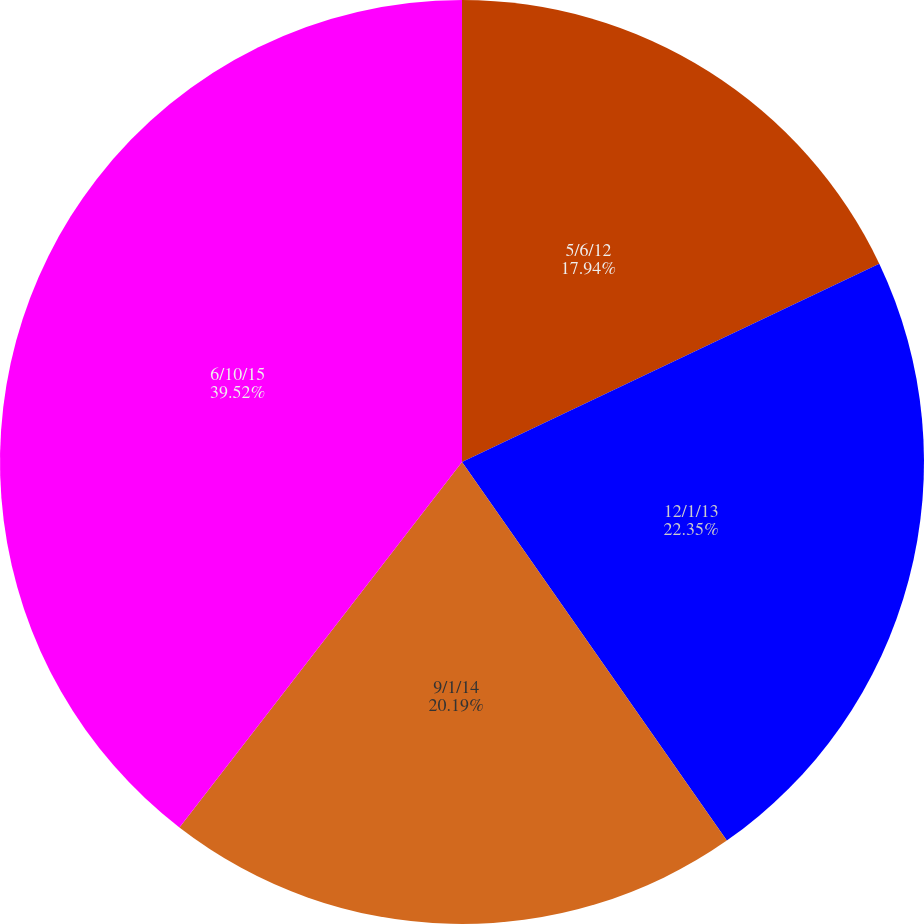<chart> <loc_0><loc_0><loc_500><loc_500><pie_chart><fcel>5/6/12<fcel>12/1/13<fcel>9/1/14<fcel>6/10/15<nl><fcel>17.94%<fcel>22.35%<fcel>20.19%<fcel>39.53%<nl></chart> 